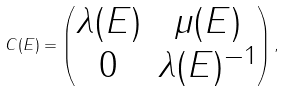<formula> <loc_0><loc_0><loc_500><loc_500>C ( E ) = \begin{pmatrix} \lambda ( E ) & \mu ( E ) \\ 0 & \lambda ( E ) ^ { - 1 } \end{pmatrix} ,</formula> 